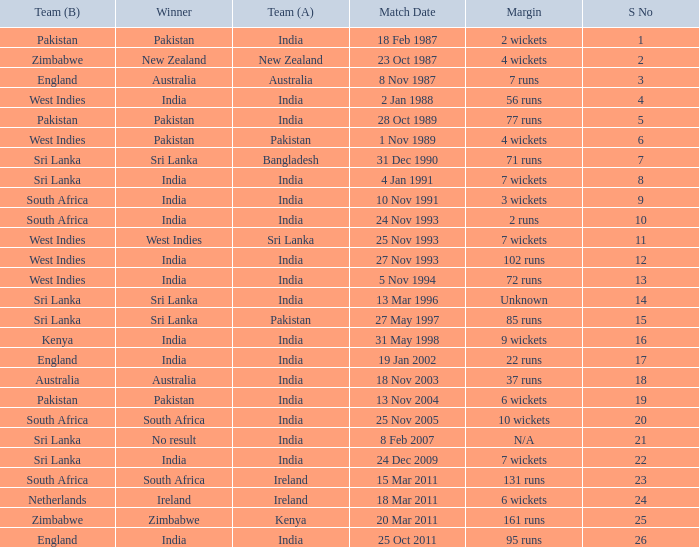What date did the West Indies win the match? 25 Nov 1993. 